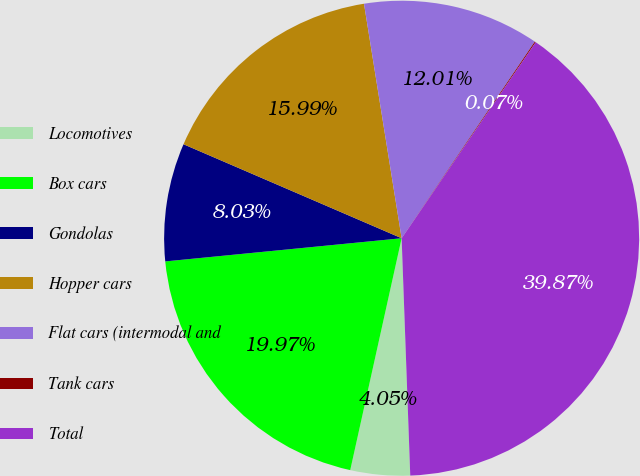<chart> <loc_0><loc_0><loc_500><loc_500><pie_chart><fcel>Locomotives<fcel>Box cars<fcel>Gondolas<fcel>Hopper cars<fcel>Flat cars (intermodal and<fcel>Tank cars<fcel>Total<nl><fcel>4.05%<fcel>19.97%<fcel>8.03%<fcel>15.99%<fcel>12.01%<fcel>0.07%<fcel>39.87%<nl></chart> 